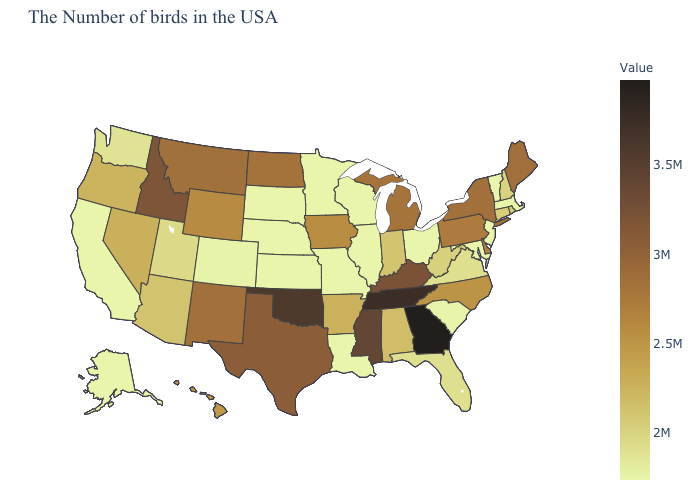Which states hav the highest value in the MidWest?
Answer briefly. North Dakota. Does Wyoming have a lower value than South Dakota?
Quick response, please. No. Does Georgia have the lowest value in the USA?
Be succinct. No. Does Massachusetts have a lower value than New Mexico?
Keep it brief. Yes. Does Washington have the lowest value in the USA?
Write a very short answer. No. Among the states that border Alabama , which have the highest value?
Write a very short answer. Georgia. Which states have the highest value in the USA?
Write a very short answer. Georgia. Is the legend a continuous bar?
Quick response, please. Yes. 